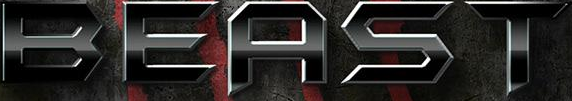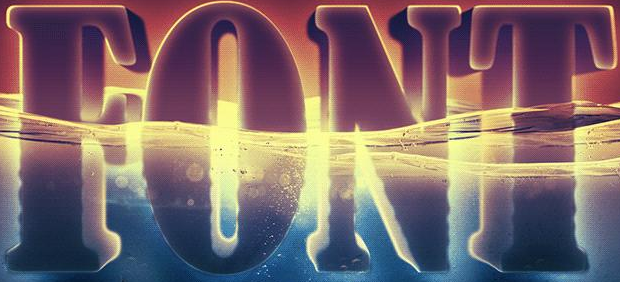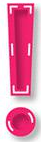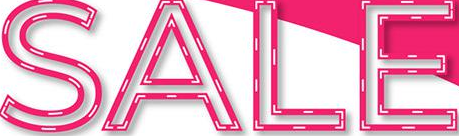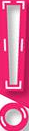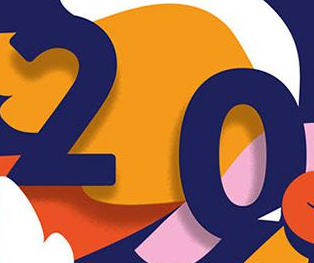What words can you see in these images in sequence, separated by a semicolon? BEAST; FONT; !; SALE; !; 20 